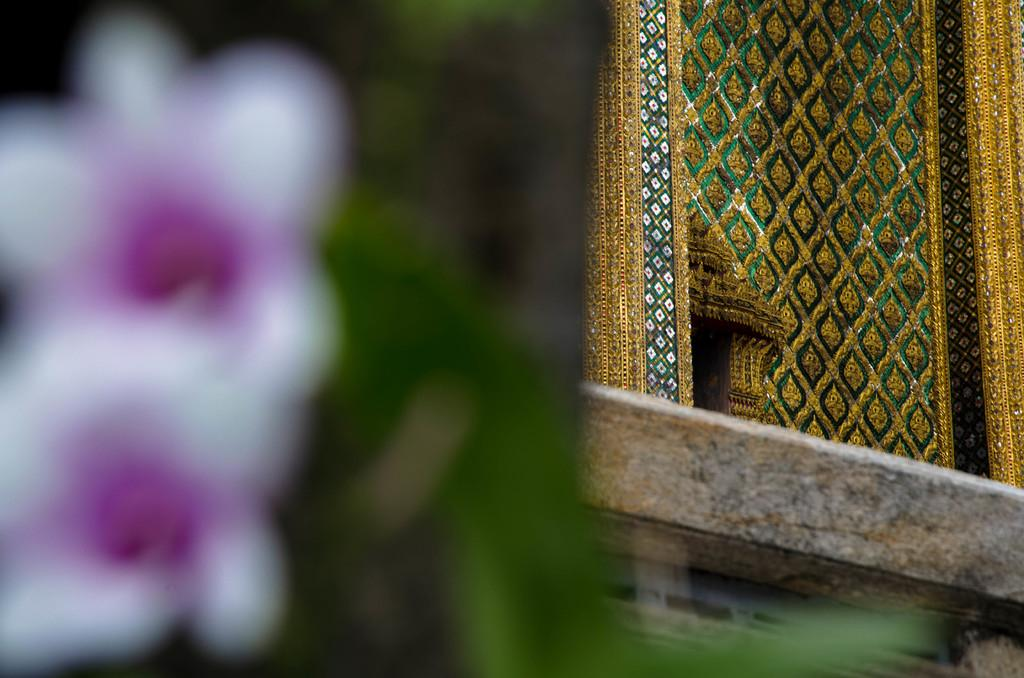What type of cloth is featured in the image? There is a designer cloth in the image. What type of mint can be seen growing near the designer cloth in the image? There is no mint present in the image; it only features a designer cloth. 